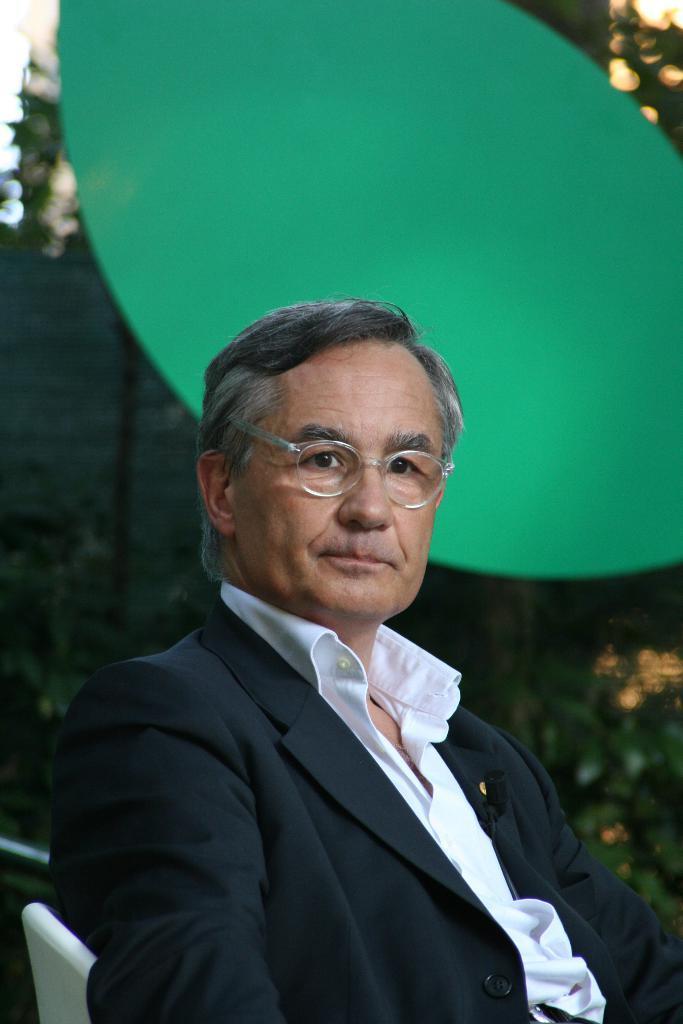Can you describe this image briefly? There is one person sitting on a white color chair and wearing a black color blazer at the bottom of this image. It seems like there are some plants in the background. 